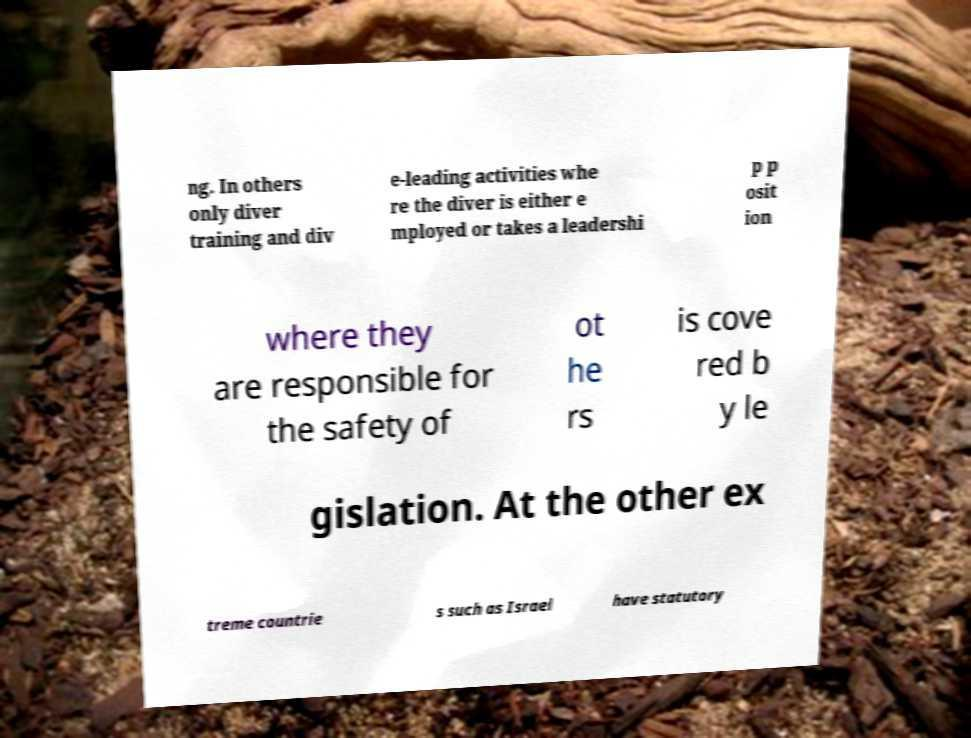Could you extract and type out the text from this image? ng. In others only diver training and div e-leading activities whe re the diver is either e mployed or takes a leadershi p p osit ion where they are responsible for the safety of ot he rs is cove red b y le gislation. At the other ex treme countrie s such as Israel have statutory 